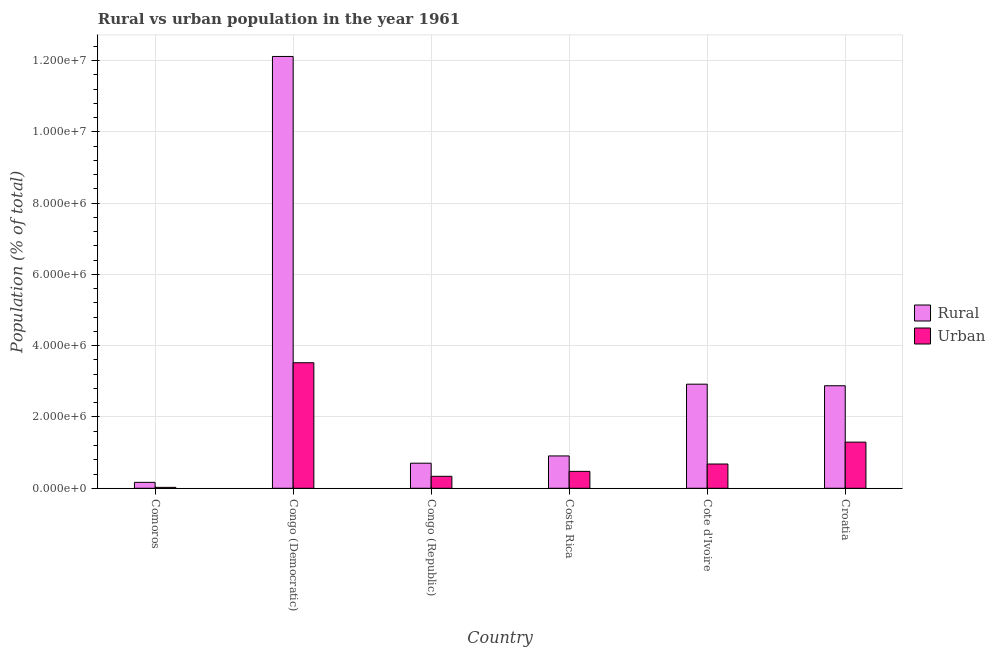Are the number of bars on each tick of the X-axis equal?
Offer a terse response. Yes. What is the label of the 1st group of bars from the left?
Your answer should be compact. Comoros. What is the urban population density in Congo (Democratic)?
Ensure brevity in your answer.  3.52e+06. Across all countries, what is the maximum rural population density?
Your answer should be compact. 1.21e+07. Across all countries, what is the minimum rural population density?
Offer a very short reply. 1.66e+05. In which country was the urban population density maximum?
Make the answer very short. Congo (Democratic). In which country was the urban population density minimum?
Provide a short and direct response. Comoros. What is the total urban population density in the graph?
Offer a very short reply. 6.33e+06. What is the difference between the rural population density in Comoros and that in Cote d'Ivoire?
Give a very brief answer. -2.75e+06. What is the difference between the rural population density in Croatia and the urban population density in Congo (Democratic)?
Give a very brief answer. -6.45e+05. What is the average rural population density per country?
Provide a succinct answer. 3.28e+06. What is the difference between the urban population density and rural population density in Cote d'Ivoire?
Provide a short and direct response. -2.24e+06. What is the ratio of the urban population density in Congo (Republic) to that in Cote d'Ivoire?
Keep it short and to the point. 0.49. Is the difference between the urban population density in Congo (Democratic) and Croatia greater than the difference between the rural population density in Congo (Democratic) and Croatia?
Your response must be concise. No. What is the difference between the highest and the second highest urban population density?
Offer a terse response. 2.23e+06. What is the difference between the highest and the lowest urban population density?
Offer a terse response. 3.50e+06. In how many countries, is the urban population density greater than the average urban population density taken over all countries?
Offer a terse response. 2. What does the 2nd bar from the left in Congo (Republic) represents?
Your response must be concise. Urban. What does the 2nd bar from the right in Cote d'Ivoire represents?
Provide a succinct answer. Rural. How many bars are there?
Ensure brevity in your answer.  12. Does the graph contain grids?
Offer a very short reply. Yes. How many legend labels are there?
Give a very brief answer. 2. How are the legend labels stacked?
Keep it short and to the point. Vertical. What is the title of the graph?
Your answer should be very brief. Rural vs urban population in the year 1961. Does "Primary" appear as one of the legend labels in the graph?
Offer a terse response. No. What is the label or title of the X-axis?
Provide a short and direct response. Country. What is the label or title of the Y-axis?
Give a very brief answer. Population (% of total). What is the Population (% of total) of Rural in Comoros?
Keep it short and to the point. 1.66e+05. What is the Population (% of total) in Urban in Comoros?
Provide a short and direct response. 2.56e+04. What is the Population (% of total) of Rural in Congo (Democratic)?
Provide a succinct answer. 1.21e+07. What is the Population (% of total) of Urban in Congo (Democratic)?
Offer a very short reply. 3.52e+06. What is the Population (% of total) in Rural in Congo (Republic)?
Your response must be concise. 7.04e+05. What is the Population (% of total) in Urban in Congo (Republic)?
Your answer should be very brief. 3.36e+05. What is the Population (% of total) of Rural in Costa Rica?
Give a very brief answer. 9.08e+05. What is the Population (% of total) of Urban in Costa Rica?
Your answer should be compact. 4.74e+05. What is the Population (% of total) of Rural in Cote d'Ivoire?
Your response must be concise. 2.92e+06. What is the Population (% of total) of Urban in Cote d'Ivoire?
Keep it short and to the point. 6.81e+05. What is the Population (% of total) of Rural in Croatia?
Your response must be concise. 2.88e+06. What is the Population (% of total) of Urban in Croatia?
Make the answer very short. 1.29e+06. Across all countries, what is the maximum Population (% of total) in Rural?
Your response must be concise. 1.21e+07. Across all countries, what is the maximum Population (% of total) of Urban?
Offer a very short reply. 3.52e+06. Across all countries, what is the minimum Population (% of total) in Rural?
Your response must be concise. 1.66e+05. Across all countries, what is the minimum Population (% of total) in Urban?
Offer a terse response. 2.56e+04. What is the total Population (% of total) in Rural in the graph?
Offer a terse response. 1.97e+07. What is the total Population (% of total) of Urban in the graph?
Your response must be concise. 6.33e+06. What is the difference between the Population (% of total) of Rural in Comoros and that in Congo (Democratic)?
Ensure brevity in your answer.  -1.19e+07. What is the difference between the Population (% of total) in Urban in Comoros and that in Congo (Democratic)?
Keep it short and to the point. -3.50e+06. What is the difference between the Population (% of total) in Rural in Comoros and that in Congo (Republic)?
Offer a terse response. -5.38e+05. What is the difference between the Population (% of total) of Urban in Comoros and that in Congo (Republic)?
Give a very brief answer. -3.10e+05. What is the difference between the Population (% of total) in Rural in Comoros and that in Costa Rica?
Make the answer very short. -7.41e+05. What is the difference between the Population (% of total) of Urban in Comoros and that in Costa Rica?
Give a very brief answer. -4.49e+05. What is the difference between the Population (% of total) in Rural in Comoros and that in Cote d'Ivoire?
Offer a very short reply. -2.75e+06. What is the difference between the Population (% of total) of Urban in Comoros and that in Cote d'Ivoire?
Keep it short and to the point. -6.56e+05. What is the difference between the Population (% of total) of Rural in Comoros and that in Croatia?
Ensure brevity in your answer.  -2.71e+06. What is the difference between the Population (% of total) of Urban in Comoros and that in Croatia?
Provide a succinct answer. -1.27e+06. What is the difference between the Population (% of total) in Rural in Congo (Democratic) and that in Congo (Republic)?
Make the answer very short. 1.14e+07. What is the difference between the Population (% of total) in Urban in Congo (Democratic) and that in Congo (Republic)?
Give a very brief answer. 3.19e+06. What is the difference between the Population (% of total) in Rural in Congo (Democratic) and that in Costa Rica?
Provide a short and direct response. 1.12e+07. What is the difference between the Population (% of total) of Urban in Congo (Democratic) and that in Costa Rica?
Provide a succinct answer. 3.05e+06. What is the difference between the Population (% of total) in Rural in Congo (Democratic) and that in Cote d'Ivoire?
Offer a terse response. 9.19e+06. What is the difference between the Population (% of total) in Urban in Congo (Democratic) and that in Cote d'Ivoire?
Offer a terse response. 2.84e+06. What is the difference between the Population (% of total) in Rural in Congo (Democratic) and that in Croatia?
Provide a succinct answer. 9.24e+06. What is the difference between the Population (% of total) of Urban in Congo (Democratic) and that in Croatia?
Make the answer very short. 2.23e+06. What is the difference between the Population (% of total) in Rural in Congo (Republic) and that in Costa Rica?
Offer a very short reply. -2.04e+05. What is the difference between the Population (% of total) of Urban in Congo (Republic) and that in Costa Rica?
Offer a very short reply. -1.38e+05. What is the difference between the Population (% of total) of Rural in Congo (Republic) and that in Cote d'Ivoire?
Provide a short and direct response. -2.22e+06. What is the difference between the Population (% of total) of Urban in Congo (Republic) and that in Cote d'Ivoire?
Provide a succinct answer. -3.45e+05. What is the difference between the Population (% of total) of Rural in Congo (Republic) and that in Croatia?
Your answer should be very brief. -2.17e+06. What is the difference between the Population (% of total) in Urban in Congo (Republic) and that in Croatia?
Keep it short and to the point. -9.59e+05. What is the difference between the Population (% of total) of Rural in Costa Rica and that in Cote d'Ivoire?
Give a very brief answer. -2.01e+06. What is the difference between the Population (% of total) in Urban in Costa Rica and that in Cote d'Ivoire?
Provide a succinct answer. -2.07e+05. What is the difference between the Population (% of total) of Rural in Costa Rica and that in Croatia?
Your answer should be compact. -1.97e+06. What is the difference between the Population (% of total) of Urban in Costa Rica and that in Croatia?
Offer a terse response. -8.20e+05. What is the difference between the Population (% of total) of Rural in Cote d'Ivoire and that in Croatia?
Provide a succinct answer. 4.41e+04. What is the difference between the Population (% of total) in Urban in Cote d'Ivoire and that in Croatia?
Give a very brief answer. -6.14e+05. What is the difference between the Population (% of total) of Rural in Comoros and the Population (% of total) of Urban in Congo (Democratic)?
Keep it short and to the point. -3.36e+06. What is the difference between the Population (% of total) of Rural in Comoros and the Population (% of total) of Urban in Congo (Republic)?
Your answer should be very brief. -1.70e+05. What is the difference between the Population (% of total) of Rural in Comoros and the Population (% of total) of Urban in Costa Rica?
Give a very brief answer. -3.08e+05. What is the difference between the Population (% of total) in Rural in Comoros and the Population (% of total) in Urban in Cote d'Ivoire?
Offer a terse response. -5.15e+05. What is the difference between the Population (% of total) in Rural in Comoros and the Population (% of total) in Urban in Croatia?
Keep it short and to the point. -1.13e+06. What is the difference between the Population (% of total) in Rural in Congo (Democratic) and the Population (% of total) in Urban in Congo (Republic)?
Your answer should be compact. 1.18e+07. What is the difference between the Population (% of total) in Rural in Congo (Democratic) and the Population (% of total) in Urban in Costa Rica?
Your response must be concise. 1.16e+07. What is the difference between the Population (% of total) of Rural in Congo (Democratic) and the Population (% of total) of Urban in Cote d'Ivoire?
Your response must be concise. 1.14e+07. What is the difference between the Population (% of total) in Rural in Congo (Democratic) and the Population (% of total) in Urban in Croatia?
Offer a terse response. 1.08e+07. What is the difference between the Population (% of total) of Rural in Congo (Republic) and the Population (% of total) of Urban in Costa Rica?
Provide a succinct answer. 2.29e+05. What is the difference between the Population (% of total) in Rural in Congo (Republic) and the Population (% of total) in Urban in Cote d'Ivoire?
Offer a terse response. 2.27e+04. What is the difference between the Population (% of total) in Rural in Congo (Republic) and the Population (% of total) in Urban in Croatia?
Keep it short and to the point. -5.91e+05. What is the difference between the Population (% of total) in Rural in Costa Rica and the Population (% of total) in Urban in Cote d'Ivoire?
Provide a short and direct response. 2.26e+05. What is the difference between the Population (% of total) in Rural in Costa Rica and the Population (% of total) in Urban in Croatia?
Your answer should be compact. -3.87e+05. What is the difference between the Population (% of total) in Rural in Cote d'Ivoire and the Population (% of total) in Urban in Croatia?
Ensure brevity in your answer.  1.63e+06. What is the average Population (% of total) of Rural per country?
Give a very brief answer. 3.28e+06. What is the average Population (% of total) of Urban per country?
Your response must be concise. 1.06e+06. What is the difference between the Population (% of total) of Rural and Population (% of total) of Urban in Comoros?
Give a very brief answer. 1.41e+05. What is the difference between the Population (% of total) in Rural and Population (% of total) in Urban in Congo (Democratic)?
Your answer should be compact. 8.59e+06. What is the difference between the Population (% of total) in Rural and Population (% of total) in Urban in Congo (Republic)?
Ensure brevity in your answer.  3.68e+05. What is the difference between the Population (% of total) in Rural and Population (% of total) in Urban in Costa Rica?
Offer a very short reply. 4.33e+05. What is the difference between the Population (% of total) of Rural and Population (% of total) of Urban in Cote d'Ivoire?
Provide a succinct answer. 2.24e+06. What is the difference between the Population (% of total) in Rural and Population (% of total) in Urban in Croatia?
Ensure brevity in your answer.  1.58e+06. What is the ratio of the Population (% of total) in Rural in Comoros to that in Congo (Democratic)?
Ensure brevity in your answer.  0.01. What is the ratio of the Population (% of total) of Urban in Comoros to that in Congo (Democratic)?
Provide a succinct answer. 0.01. What is the ratio of the Population (% of total) of Rural in Comoros to that in Congo (Republic)?
Ensure brevity in your answer.  0.24. What is the ratio of the Population (% of total) in Urban in Comoros to that in Congo (Republic)?
Give a very brief answer. 0.08. What is the ratio of the Population (% of total) in Rural in Comoros to that in Costa Rica?
Provide a short and direct response. 0.18. What is the ratio of the Population (% of total) of Urban in Comoros to that in Costa Rica?
Keep it short and to the point. 0.05. What is the ratio of the Population (% of total) in Rural in Comoros to that in Cote d'Ivoire?
Your response must be concise. 0.06. What is the ratio of the Population (% of total) in Urban in Comoros to that in Cote d'Ivoire?
Provide a short and direct response. 0.04. What is the ratio of the Population (% of total) of Rural in Comoros to that in Croatia?
Offer a terse response. 0.06. What is the ratio of the Population (% of total) of Urban in Comoros to that in Croatia?
Your answer should be very brief. 0.02. What is the ratio of the Population (% of total) in Rural in Congo (Democratic) to that in Congo (Republic)?
Your answer should be very brief. 17.21. What is the ratio of the Population (% of total) of Urban in Congo (Democratic) to that in Congo (Republic)?
Make the answer very short. 10.48. What is the ratio of the Population (% of total) of Rural in Congo (Democratic) to that in Costa Rica?
Offer a terse response. 13.35. What is the ratio of the Population (% of total) in Urban in Congo (Democratic) to that in Costa Rica?
Your response must be concise. 7.42. What is the ratio of the Population (% of total) in Rural in Congo (Democratic) to that in Cote d'Ivoire?
Ensure brevity in your answer.  4.15. What is the ratio of the Population (% of total) of Urban in Congo (Democratic) to that in Cote d'Ivoire?
Make the answer very short. 5.17. What is the ratio of the Population (% of total) of Rural in Congo (Democratic) to that in Croatia?
Keep it short and to the point. 4.21. What is the ratio of the Population (% of total) in Urban in Congo (Democratic) to that in Croatia?
Provide a succinct answer. 2.72. What is the ratio of the Population (% of total) of Rural in Congo (Republic) to that in Costa Rica?
Keep it short and to the point. 0.78. What is the ratio of the Population (% of total) in Urban in Congo (Republic) to that in Costa Rica?
Provide a short and direct response. 0.71. What is the ratio of the Population (% of total) of Rural in Congo (Republic) to that in Cote d'Ivoire?
Give a very brief answer. 0.24. What is the ratio of the Population (% of total) of Urban in Congo (Republic) to that in Cote d'Ivoire?
Make the answer very short. 0.49. What is the ratio of the Population (% of total) in Rural in Congo (Republic) to that in Croatia?
Make the answer very short. 0.24. What is the ratio of the Population (% of total) in Urban in Congo (Republic) to that in Croatia?
Keep it short and to the point. 0.26. What is the ratio of the Population (% of total) of Rural in Costa Rica to that in Cote d'Ivoire?
Your response must be concise. 0.31. What is the ratio of the Population (% of total) of Urban in Costa Rica to that in Cote d'Ivoire?
Give a very brief answer. 0.7. What is the ratio of the Population (% of total) of Rural in Costa Rica to that in Croatia?
Provide a short and direct response. 0.32. What is the ratio of the Population (% of total) in Urban in Costa Rica to that in Croatia?
Provide a short and direct response. 0.37. What is the ratio of the Population (% of total) of Rural in Cote d'Ivoire to that in Croatia?
Your response must be concise. 1.02. What is the ratio of the Population (% of total) of Urban in Cote d'Ivoire to that in Croatia?
Your response must be concise. 0.53. What is the difference between the highest and the second highest Population (% of total) in Rural?
Offer a terse response. 9.19e+06. What is the difference between the highest and the second highest Population (% of total) of Urban?
Your answer should be very brief. 2.23e+06. What is the difference between the highest and the lowest Population (% of total) in Rural?
Give a very brief answer. 1.19e+07. What is the difference between the highest and the lowest Population (% of total) of Urban?
Your response must be concise. 3.50e+06. 